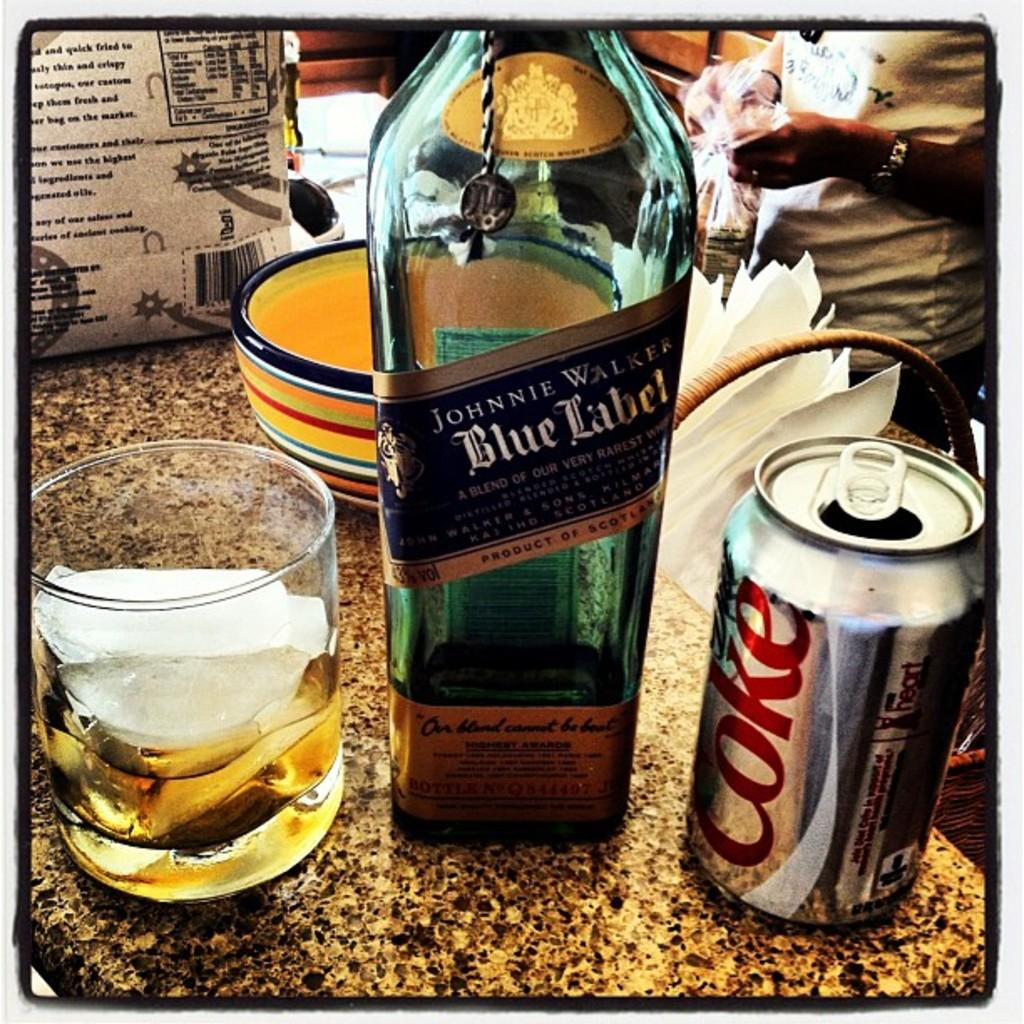<image>
Provide a brief description of the given image. A bottle of Johnnie Walker Blue Label and a diet Coke. 